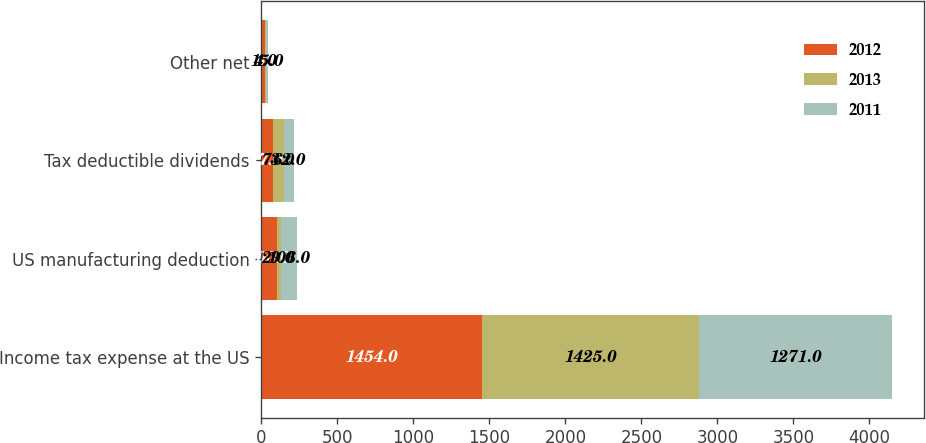Convert chart. <chart><loc_0><loc_0><loc_500><loc_500><stacked_bar_chart><ecel><fcel>Income tax expense at the US<fcel>US manufacturing deduction<fcel>Tax deductible dividends<fcel>Other net<nl><fcel>2012<fcel>1454<fcel>100<fcel>77<fcel>26<nl><fcel>2013<fcel>1425<fcel>29<fcel>73<fcel>4<nl><fcel>2011<fcel>1271<fcel>106<fcel>62<fcel>15<nl></chart> 